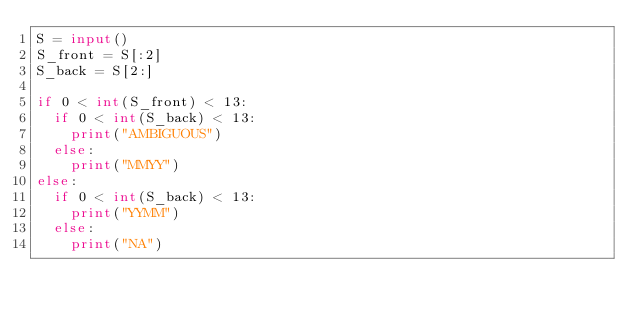<code> <loc_0><loc_0><loc_500><loc_500><_Python_>S = input()
S_front = S[:2]
S_back = S[2:]

if 0 < int(S_front) < 13:
	if 0 < int(S_back) < 13:
		print("AMBIGUOUS")
	else:
		print("MMYY")
else:
	if 0 < int(S_back) < 13:
		print("YYMM")
	else:
		print("NA")</code> 